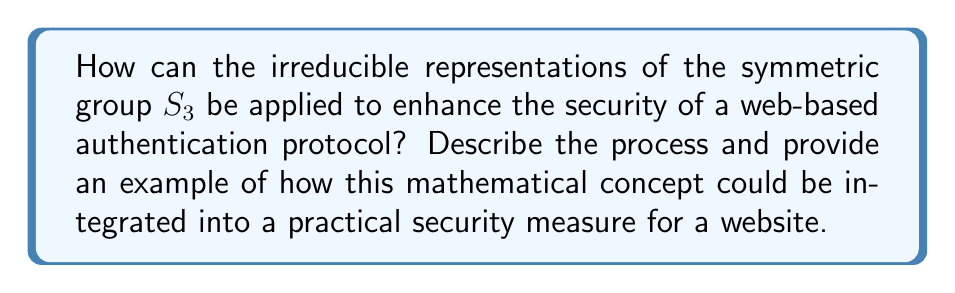Provide a solution to this math problem. To answer this question, let's break it down into steps:

1. Understand the symmetric group S3:
   S3 is the group of all permutations on 3 elements. It has 6 elements: {e, (12), (13), (23), (123), (132)}.

2. Calculate the irreducible representations of S3:
   S3 has three irreducible representations:
   a) The trivial representation (1-dimensional)
   b) The sign representation (1-dimensional)
   c) The standard representation (2-dimensional)

3. Express these representations mathematically:
   a) Trivial: $\rho_1(g) = 1$ for all $g \in S3$
   b) Sign: $\rho_2(g) = \text{sgn}(g)$ where $\text{sgn}(g) = 1$ for even permutations and $-1$ for odd permutations
   c) Standard: For $g \in S3$, $\rho_3(g)$ is a 2x2 matrix:
      $$\rho_3(e) = \begin{pmatrix} 1 & 0 \\ 0 & 1 \end{pmatrix}$$
      $$\rho_3((12)) = \begin{pmatrix} -1/2 & \sqrt{3}/2 \\ \sqrt{3}/2 & 1/2 \end{pmatrix}$$
      (Other elements can be calculated similarly)

4. Apply to web security:
   These representations can be used to create a unique mathematical fingerprint for user authentication. For example:

   a) Generate a random permutation in S3 for each login attempt
   b) Apply all three irreducible representations to this permutation
   c) Combine the results to create a unique identifier

5. Implementation example:
   Let's say a user attempts to log in. The server generates a random permutation, e.g., (123).
   
   Calculate:
   $\rho_1((123)) = 1$
   $\rho_2((123)) = 1$ (even permutation)
   $$\rho_3((123)) = \begin{pmatrix} -1/2 & -\sqrt{3}/2 \\ \sqrt{3}/2 & -1/2 \end{pmatrix}$$

   Combine these results to create a unique identifier, such as a hash of the matrix elements.

6. Security enhancement:
   This method adds an extra layer of security by:
   a) Creating a dynamic, session-specific identifier
   b) Making it computationally difficult for an attacker to predict or replicate
   c) Allowing for easy integration with existing hashing and encryption methods

By incorporating this mathematical concept into the authentication process, a web designer can significantly enhance the security of their website against various attacks, such as replay attacks or session hijacking.
Answer: Irreducible representations of S3 can be used to generate unique, session-specific identifiers in web authentication protocols, enhancing security against replay attacks and session hijacking. 